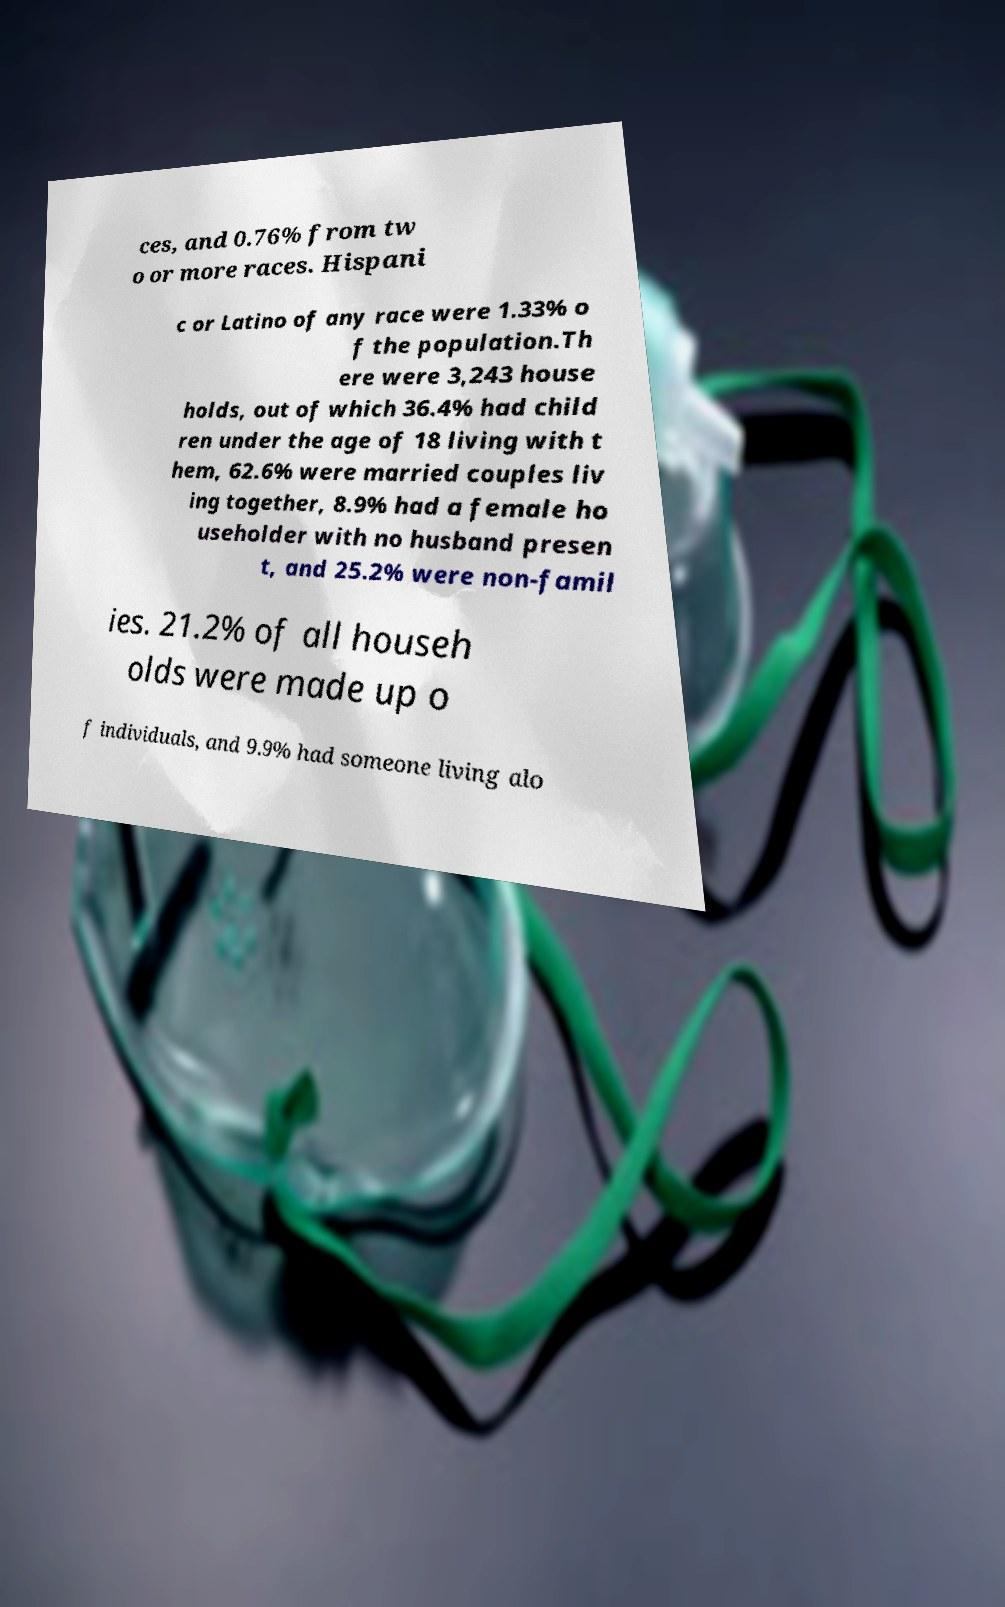Could you extract and type out the text from this image? ces, and 0.76% from tw o or more races. Hispani c or Latino of any race were 1.33% o f the population.Th ere were 3,243 house holds, out of which 36.4% had child ren under the age of 18 living with t hem, 62.6% were married couples liv ing together, 8.9% had a female ho useholder with no husband presen t, and 25.2% were non-famil ies. 21.2% of all househ olds were made up o f individuals, and 9.9% had someone living alo 